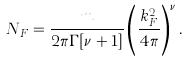<formula> <loc_0><loc_0><loc_500><loc_500>N _ { F } = \frac { m } { 2 \pi \Gamma [ \nu + 1 ] } \left ( \frac { k _ { F } ^ { 2 } } { 4 \pi } \right ) ^ { \nu } .</formula> 